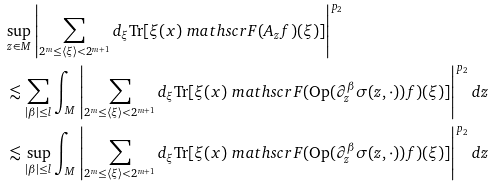<formula> <loc_0><loc_0><loc_500><loc_500>& \sup _ { z \in M } \left | \sum _ { 2 ^ { m } \leq \langle \xi \rangle < 2 ^ { m + 1 } } d _ { \xi } \text {Tr} [ \xi ( x ) \ m a t h s c r { F } ( A _ { z } f ) ( \xi ) ] \right | ^ { p _ { 2 } } \\ & \lesssim \sum _ { | \beta | \leq l } \int _ { M } \left | \sum _ { 2 ^ { m } \leq \langle \xi \rangle < 2 ^ { m + 1 } } d _ { \xi } \text {Tr} [ \xi ( x ) \ m a t h s c r { F } ( \text {Op} ( \partial ^ { \beta } _ { z } \sigma ( z , \cdot ) ) f ) ( \xi ) ] \right | ^ { p _ { 2 } } d z \\ & \lesssim \sup _ { | \beta | \leq l } \int _ { M } \left | \sum _ { 2 ^ { m } \leq \langle \xi \rangle < 2 ^ { m + 1 } } d _ { \xi } \text {Tr} [ \xi ( x ) \ m a t h s c r { F } ( \text {Op} ( \partial ^ { \beta } _ { z } \sigma ( z , \cdot ) ) f ) ( \xi ) ] \right | ^ { p _ { 2 } } d z</formula> 